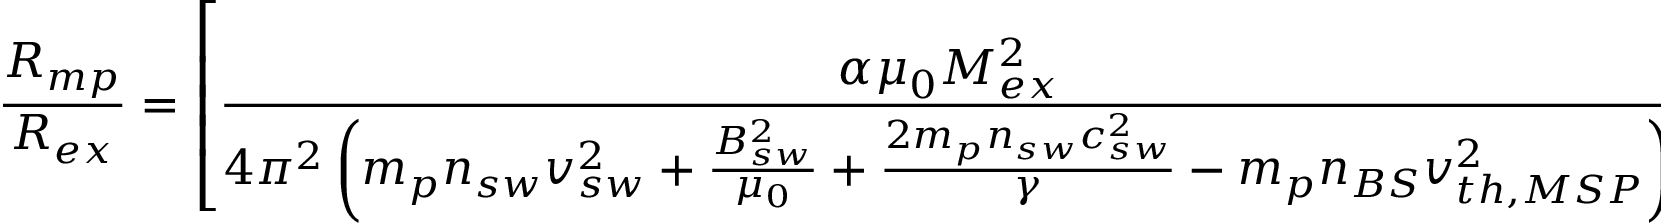Convert formula to latex. <formula><loc_0><loc_0><loc_500><loc_500>\frac { R _ { m p } } { R _ { e x } } = \left [ \frac { \alpha \mu _ { 0 } M _ { e x } ^ { 2 } } { 4 \pi ^ { 2 } \left ( m _ { p } n _ { s w } v _ { s w } ^ { 2 } + \frac { B _ { s w } ^ { 2 } } { \mu _ { 0 } } + \frac { 2 m _ { p } n _ { s w } c _ { s w } ^ { 2 } } { \gamma } - m _ { p } n _ { B S } v _ { t h , M S P } ^ { 2 } \right ) } \right ] ^ { ( 1 / 6 ) }</formula> 